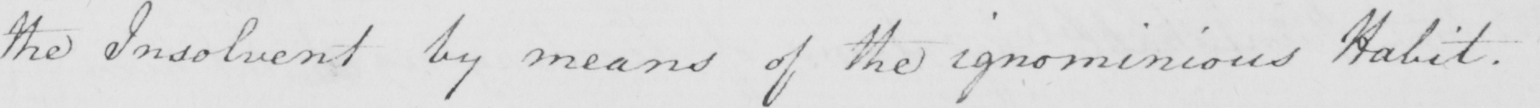Can you read and transcribe this handwriting? the Insolvent by means of the ignominious Habit . 